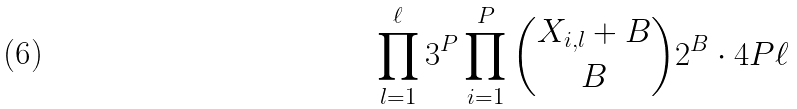Convert formula to latex. <formula><loc_0><loc_0><loc_500><loc_500>\prod _ { l = 1 } ^ { \ell } 3 ^ { P } \prod _ { i = 1 } ^ { P } { X _ { i , l } + B \choose B } 2 ^ { B } \cdot 4 P \ell</formula> 